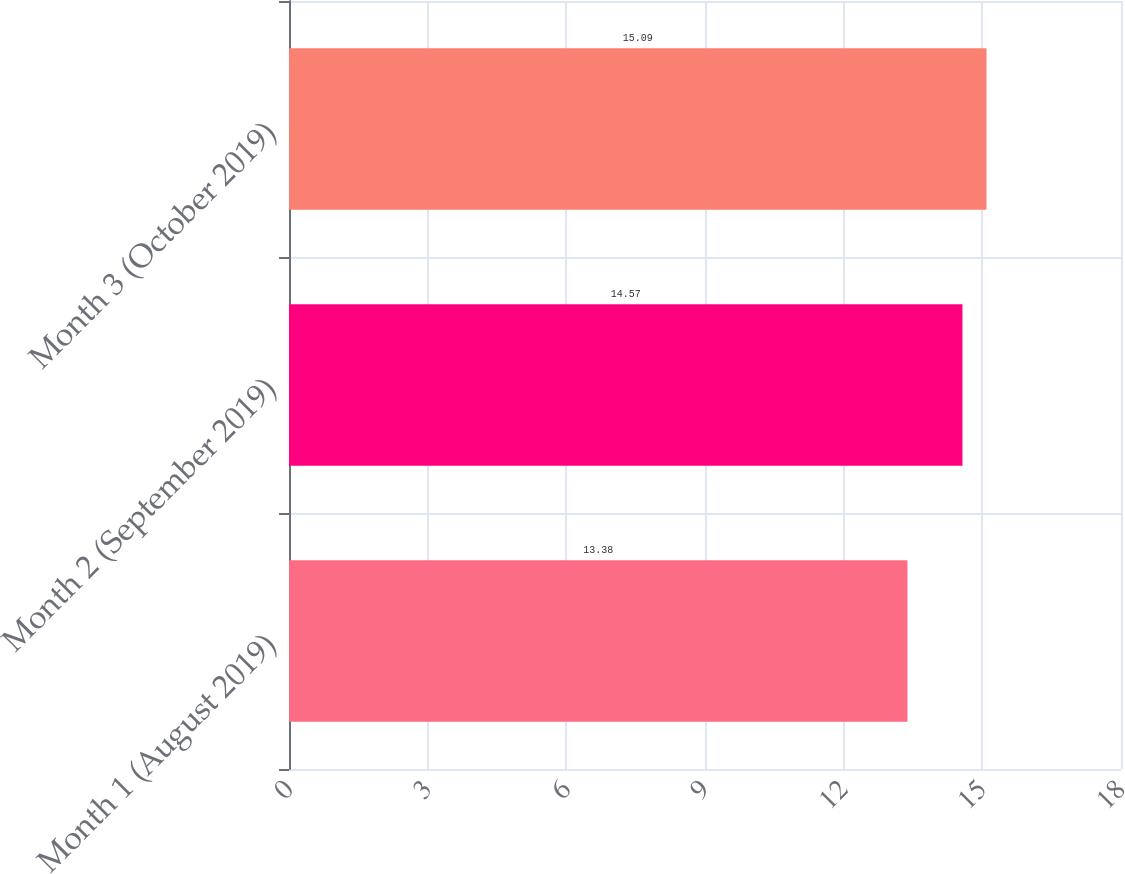Convert chart. <chart><loc_0><loc_0><loc_500><loc_500><bar_chart><fcel>Month 1 (August 2019)<fcel>Month 2 (September 2019)<fcel>Month 3 (October 2019)<nl><fcel>13.38<fcel>14.57<fcel>15.09<nl></chart> 